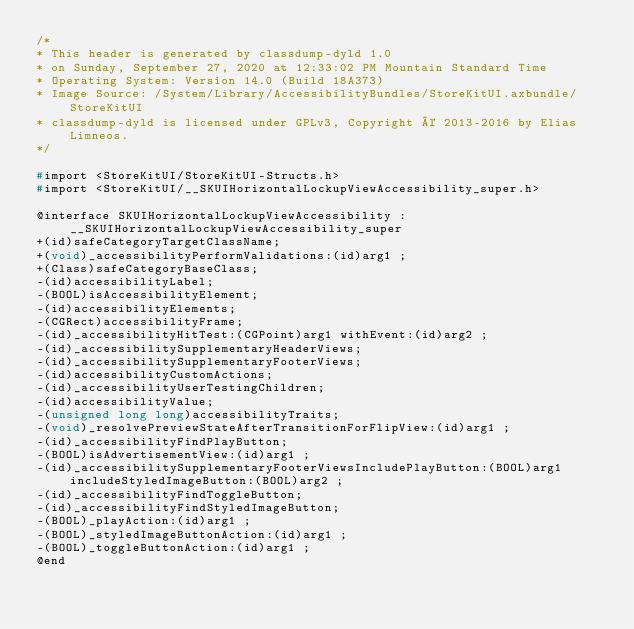Convert code to text. <code><loc_0><loc_0><loc_500><loc_500><_C_>/*
* This header is generated by classdump-dyld 1.0
* on Sunday, September 27, 2020 at 12:33:02 PM Mountain Standard Time
* Operating System: Version 14.0 (Build 18A373)
* Image Source: /System/Library/AccessibilityBundles/StoreKitUI.axbundle/StoreKitUI
* classdump-dyld is licensed under GPLv3, Copyright © 2013-2016 by Elias Limneos.
*/

#import <StoreKitUI/StoreKitUI-Structs.h>
#import <StoreKitUI/__SKUIHorizontalLockupViewAccessibility_super.h>

@interface SKUIHorizontalLockupViewAccessibility : __SKUIHorizontalLockupViewAccessibility_super
+(id)safeCategoryTargetClassName;
+(void)_accessibilityPerformValidations:(id)arg1 ;
+(Class)safeCategoryBaseClass;
-(id)accessibilityLabel;
-(BOOL)isAccessibilityElement;
-(id)accessibilityElements;
-(CGRect)accessibilityFrame;
-(id)_accessibilityHitTest:(CGPoint)arg1 withEvent:(id)arg2 ;
-(id)_accessibilitySupplementaryHeaderViews;
-(id)_accessibilitySupplementaryFooterViews;
-(id)accessibilityCustomActions;
-(id)_accessibilityUserTestingChildren;
-(id)accessibilityValue;
-(unsigned long long)accessibilityTraits;
-(void)_resolvePreviewStateAfterTransitionForFlipView:(id)arg1 ;
-(id)_accessibilityFindPlayButton;
-(BOOL)isAdvertisementView:(id)arg1 ;
-(id)_accessibilitySupplementaryFooterViewsIncludePlayButton:(BOOL)arg1 includeStyledImageButton:(BOOL)arg2 ;
-(id)_accessibilityFindToggleButton;
-(id)_accessibilityFindStyledImageButton;
-(BOOL)_playAction:(id)arg1 ;
-(BOOL)_styledImageButtonAction:(id)arg1 ;
-(BOOL)_toggleButtonAction:(id)arg1 ;
@end

</code> 